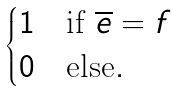Convert formula to latex. <formula><loc_0><loc_0><loc_500><loc_500>\begin{cases} 1 & \text {if } \overline { e } = f \\ 0 & \text {else} . \end{cases}</formula> 